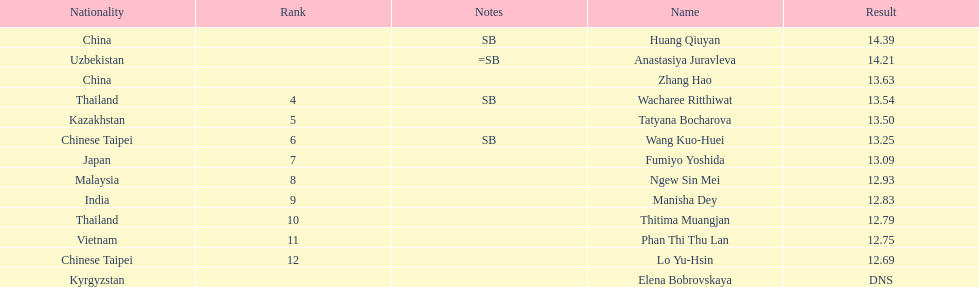Write the full table. {'header': ['Nationality', 'Rank', 'Notes', 'Name', 'Result'], 'rows': [['China', '', 'SB', 'Huang Qiuyan', '14.39'], ['Uzbekistan', '', '=SB', 'Anastasiya Juravleva', '14.21'], ['China', '', '', 'Zhang Hao', '13.63'], ['Thailand', '4', 'SB', 'Wacharee Ritthiwat', '13.54'], ['Kazakhstan', '5', '', 'Tatyana Bocharova', '13.50'], ['Chinese Taipei', '6', 'SB', 'Wang Kuo-Huei', '13.25'], ['Japan', '7', '', 'Fumiyo Yoshida', '13.09'], ['Malaysia', '8', '', 'Ngew Sin Mei', '12.93'], ['India', '9', '', 'Manisha Dey', '12.83'], ['Thailand', '10', '', 'Thitima Muangjan', '12.79'], ['Vietnam', '11', '', 'Phan Thi Thu Lan', '12.75'], ['Chinese Taipei', '12', '', 'Lo Yu-Hsin', '12.69'], ['Kyrgyzstan', '', '', 'Elena Bobrovskaya', 'DNS']]} How many competitors had less than 13.00 points? 6. 